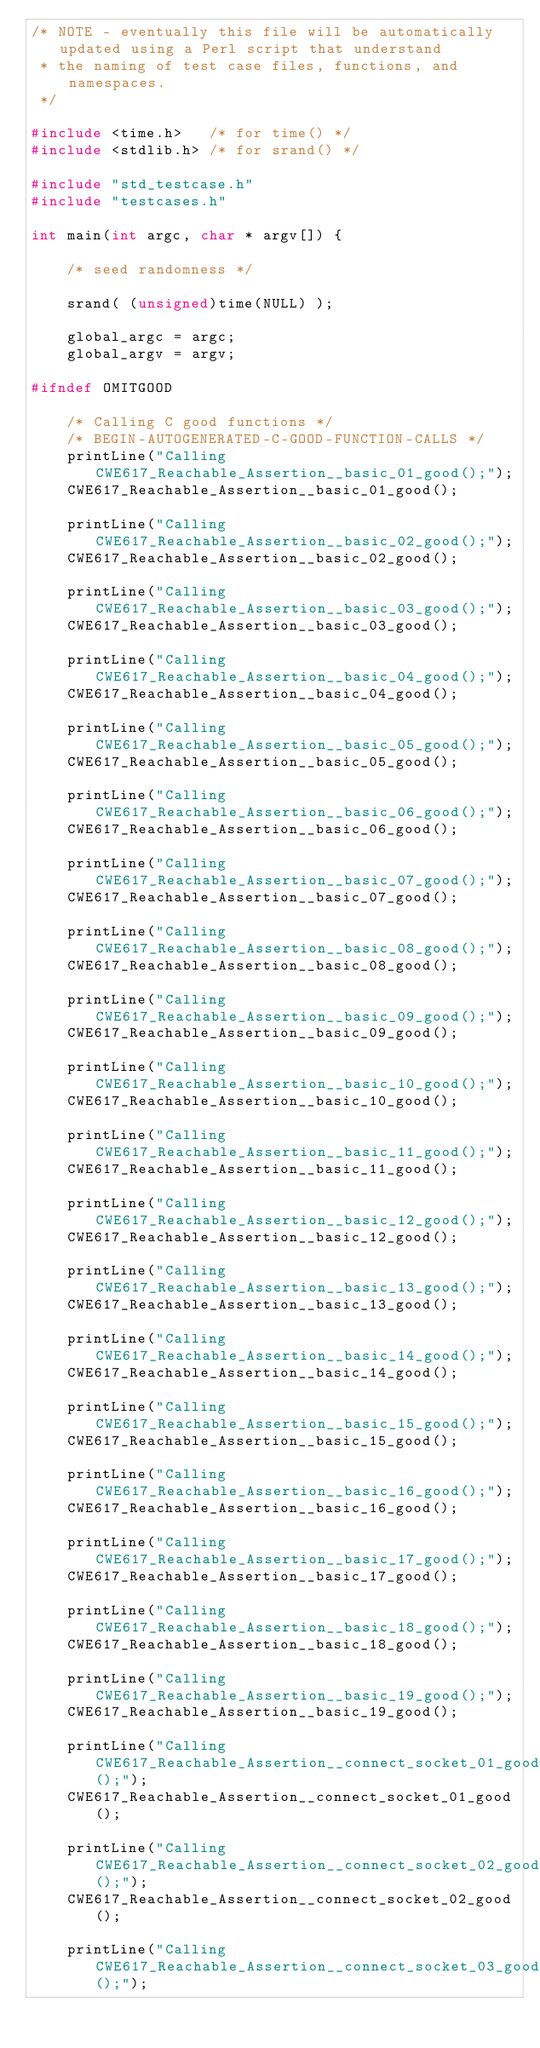Convert code to text. <code><loc_0><loc_0><loc_500><loc_500><_C++_>/* NOTE - eventually this file will be automatically updated using a Perl script that understand
 * the naming of test case files, functions, and namespaces.
 */

#include <time.h>   /* for time() */
#include <stdlib.h> /* for srand() */

#include "std_testcase.h"
#include "testcases.h"

int main(int argc, char * argv[]) {

	/* seed randomness */

	srand( (unsigned)time(NULL) );

	global_argc = argc;
	global_argv = argv;

#ifndef OMITGOOD

	/* Calling C good functions */
	/* BEGIN-AUTOGENERATED-C-GOOD-FUNCTION-CALLS */
	printLine("Calling CWE617_Reachable_Assertion__basic_01_good();");
	CWE617_Reachable_Assertion__basic_01_good();

	printLine("Calling CWE617_Reachable_Assertion__basic_02_good();");
	CWE617_Reachable_Assertion__basic_02_good();

	printLine("Calling CWE617_Reachable_Assertion__basic_03_good();");
	CWE617_Reachable_Assertion__basic_03_good();

	printLine("Calling CWE617_Reachable_Assertion__basic_04_good();");
	CWE617_Reachable_Assertion__basic_04_good();

	printLine("Calling CWE617_Reachable_Assertion__basic_05_good();");
	CWE617_Reachable_Assertion__basic_05_good();

	printLine("Calling CWE617_Reachable_Assertion__basic_06_good();");
	CWE617_Reachable_Assertion__basic_06_good();

	printLine("Calling CWE617_Reachable_Assertion__basic_07_good();");
	CWE617_Reachable_Assertion__basic_07_good();

	printLine("Calling CWE617_Reachable_Assertion__basic_08_good();");
	CWE617_Reachable_Assertion__basic_08_good();

	printLine("Calling CWE617_Reachable_Assertion__basic_09_good();");
	CWE617_Reachable_Assertion__basic_09_good();

	printLine("Calling CWE617_Reachable_Assertion__basic_10_good();");
	CWE617_Reachable_Assertion__basic_10_good();

	printLine("Calling CWE617_Reachable_Assertion__basic_11_good();");
	CWE617_Reachable_Assertion__basic_11_good();

	printLine("Calling CWE617_Reachable_Assertion__basic_12_good();");
	CWE617_Reachable_Assertion__basic_12_good();

	printLine("Calling CWE617_Reachable_Assertion__basic_13_good();");
	CWE617_Reachable_Assertion__basic_13_good();

	printLine("Calling CWE617_Reachable_Assertion__basic_14_good();");
	CWE617_Reachable_Assertion__basic_14_good();

	printLine("Calling CWE617_Reachable_Assertion__basic_15_good();");
	CWE617_Reachable_Assertion__basic_15_good();

	printLine("Calling CWE617_Reachable_Assertion__basic_16_good();");
	CWE617_Reachable_Assertion__basic_16_good();

	printLine("Calling CWE617_Reachable_Assertion__basic_17_good();");
	CWE617_Reachable_Assertion__basic_17_good();

	printLine("Calling CWE617_Reachable_Assertion__basic_18_good();");
	CWE617_Reachable_Assertion__basic_18_good();

	printLine("Calling CWE617_Reachable_Assertion__basic_19_good();");
	CWE617_Reachable_Assertion__basic_19_good();

	printLine("Calling CWE617_Reachable_Assertion__connect_socket_01_good();");
	CWE617_Reachable_Assertion__connect_socket_01_good();

	printLine("Calling CWE617_Reachable_Assertion__connect_socket_02_good();");
	CWE617_Reachable_Assertion__connect_socket_02_good();

	printLine("Calling CWE617_Reachable_Assertion__connect_socket_03_good();");</code> 